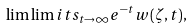<formula> <loc_0><loc_0><loc_500><loc_500>\lim \lim i t s _ { t \to \infty } e ^ { - t } w ( \zeta , t ) ,</formula> 